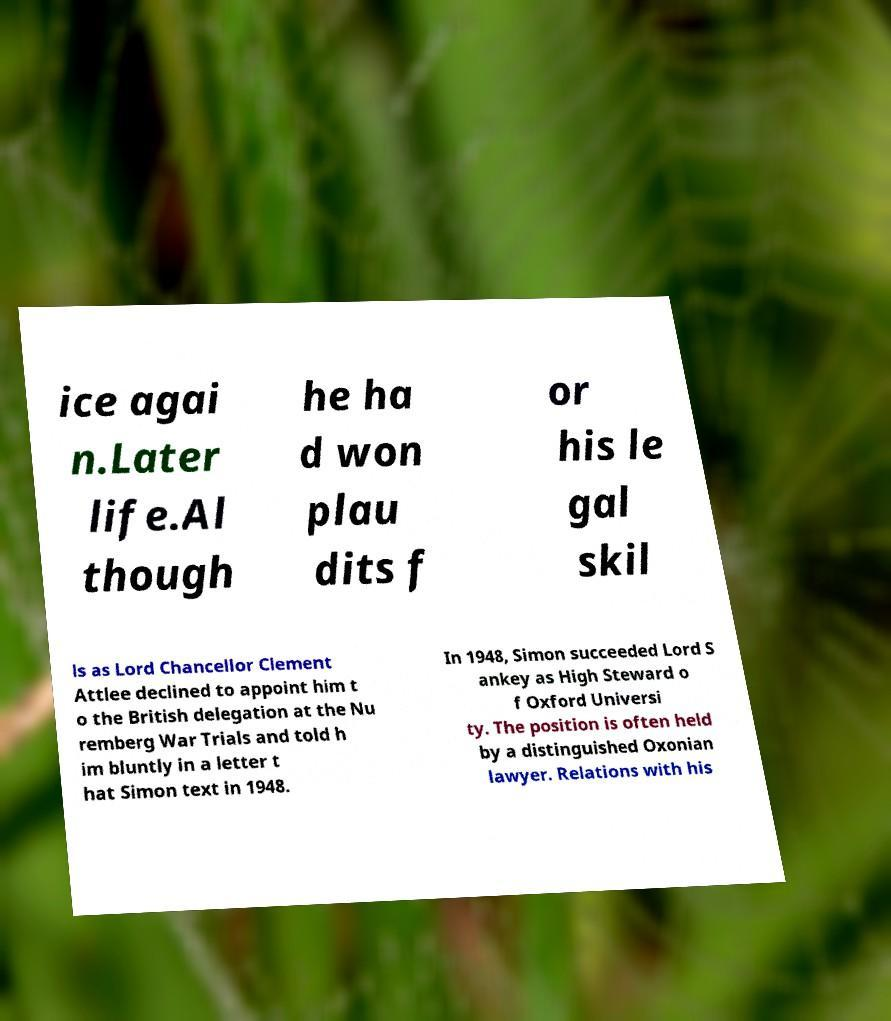Could you extract and type out the text from this image? ice agai n.Later life.Al though he ha d won plau dits f or his le gal skil ls as Lord Chancellor Clement Attlee declined to appoint him t o the British delegation at the Nu remberg War Trials and told h im bluntly in a letter t hat Simon text in 1948. In 1948, Simon succeeded Lord S ankey as High Steward o f Oxford Universi ty. The position is often held by a distinguished Oxonian lawyer. Relations with his 